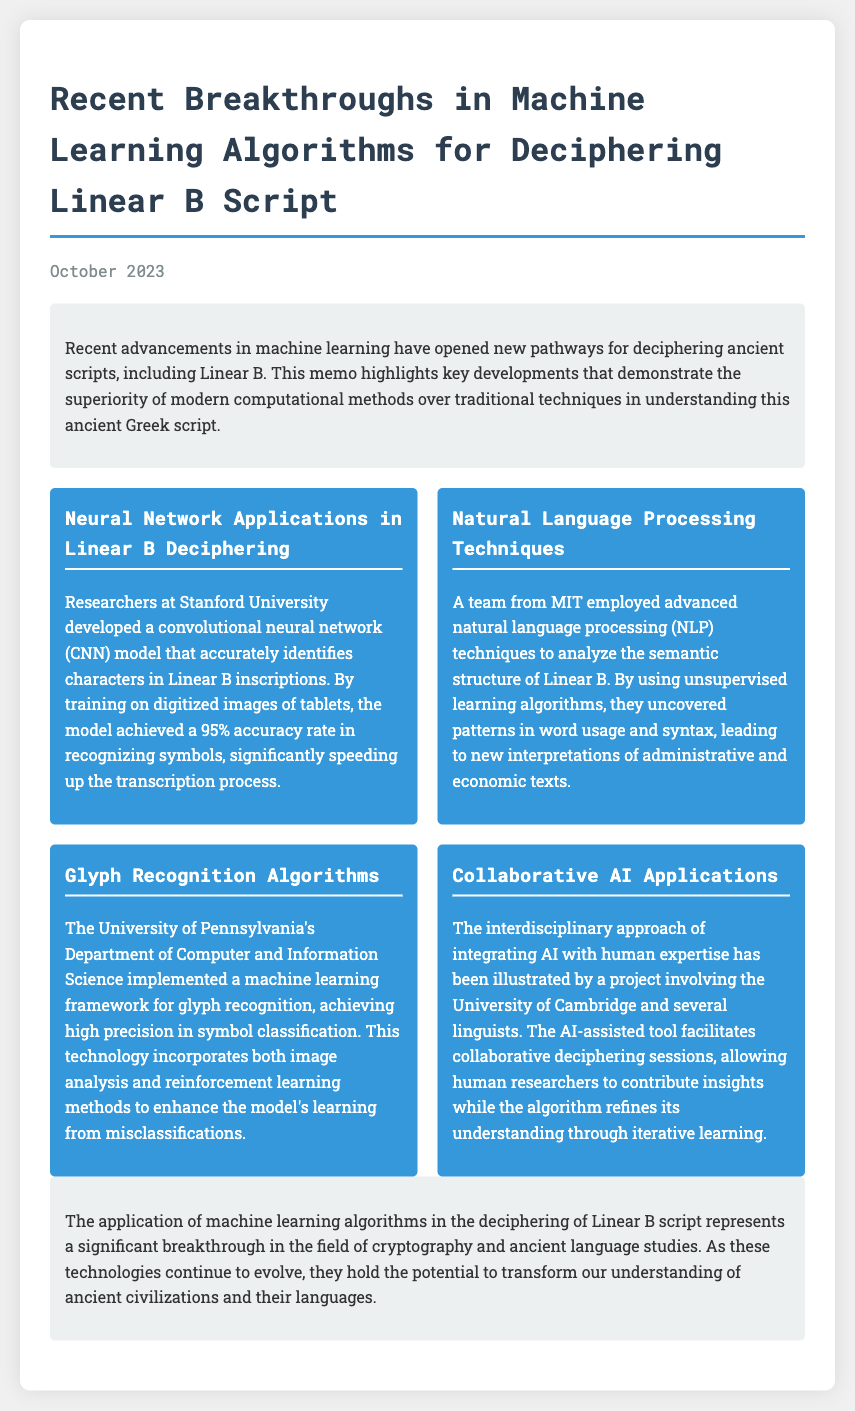What is the date of the memo? The date mentioned in the memo is October 2023.
Answer: October 2023 Who developed a convolutional neural network model for Linear B deciphering? The memo states that researchers at Stanford University developed this model.
Answer: Stanford University What accuracy rate did the CNN model achieve? The CNN model achieved a 95% accuracy rate in recognizing symbols.
Answer: 95% Which institution implemented a machine learning framework for glyph recognition? The University of Pennsylvania's Department of Computer and Information Science implemented this framework.
Answer: University of Pennsylvania What type of learning algorithms were used by MIT's team to analyze Linear B? The team employed unsupervised learning algorithms for their analysis.
Answer: Unsupervised learning algorithms What collaborative approach was illustrated by the project with the University of Cambridge? The project involved integrating AI with human expertise for collaborative deciphering.
Answer: Integrating AI with human expertise What is the primary focus of the recent advancements mentioned in the memo? The advancements focus on the application of machine learning to decipher ancient scripts.
Answer: Machine learning to decipher ancient scripts What potential do these technologies hold according to the conclusion? The technologies hold the potential to transform our understanding of ancient civilizations and their languages.
Answer: Transform our understanding of ancient civilizations and their languages 